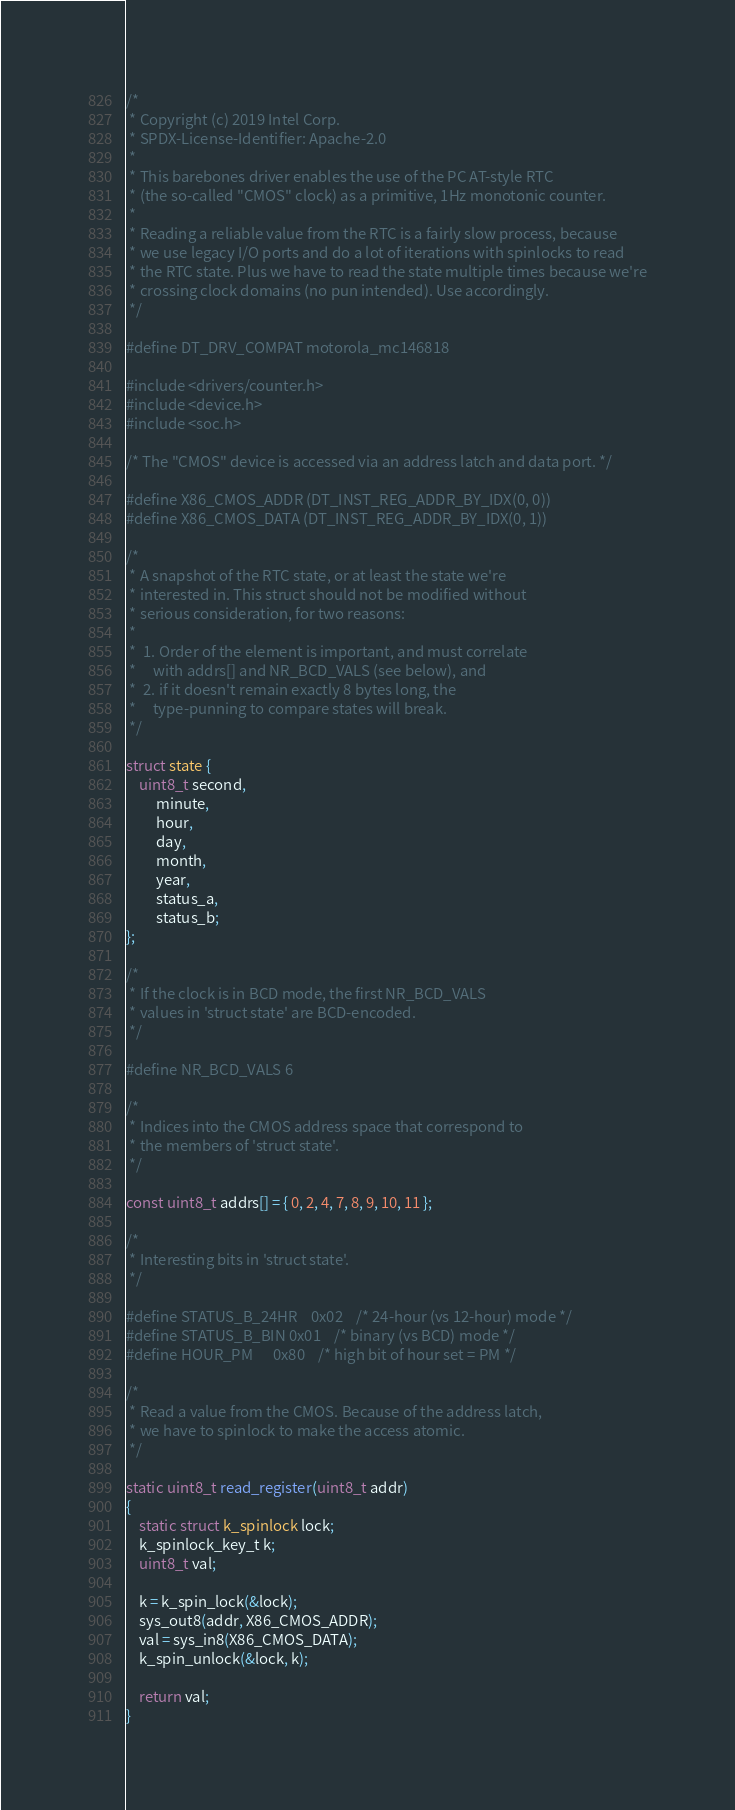<code> <loc_0><loc_0><loc_500><loc_500><_C_>/*
 * Copyright (c) 2019 Intel Corp.
 * SPDX-License-Identifier: Apache-2.0
 *
 * This barebones driver enables the use of the PC AT-style RTC
 * (the so-called "CMOS" clock) as a primitive, 1Hz monotonic counter.
 *
 * Reading a reliable value from the RTC is a fairly slow process, because
 * we use legacy I/O ports and do a lot of iterations with spinlocks to read
 * the RTC state. Plus we have to read the state multiple times because we're
 * crossing clock domains (no pun intended). Use accordingly.
 */

#define DT_DRV_COMPAT motorola_mc146818

#include <drivers/counter.h>
#include <device.h>
#include <soc.h>

/* The "CMOS" device is accessed via an address latch and data port. */

#define X86_CMOS_ADDR (DT_INST_REG_ADDR_BY_IDX(0, 0))
#define X86_CMOS_DATA (DT_INST_REG_ADDR_BY_IDX(0, 1))

/*
 * A snapshot of the RTC state, or at least the state we're
 * interested in. This struct should not be modified without
 * serious consideration, for two reasons:
 *
 *	1. Order of the element is important, and must correlate
 *	   with addrs[] and NR_BCD_VALS (see below), and
 *	2. if it doesn't remain exactly 8 bytes long, the
 *	   type-punning to compare states will break.
 */

struct state {
	uint8_t second,
	     minute,
	     hour,
	     day,
	     month,
	     year,
	     status_a,
	     status_b;
};

/*
 * If the clock is in BCD mode, the first NR_BCD_VALS
 * values in 'struct state' are BCD-encoded.
 */

#define NR_BCD_VALS 6

/*
 * Indices into the CMOS address space that correspond to
 * the members of 'struct state'.
 */

const uint8_t addrs[] = { 0, 2, 4, 7, 8, 9, 10, 11 };

/*
 * Interesting bits in 'struct state'.
 */

#define STATUS_B_24HR	0x02	/* 24-hour (vs 12-hour) mode */
#define STATUS_B_BIN	0x01	/* binary (vs BCD) mode */
#define HOUR_PM		0x80	/* high bit of hour set = PM */

/*
 * Read a value from the CMOS. Because of the address latch,
 * we have to spinlock to make the access atomic.
 */

static uint8_t read_register(uint8_t addr)
{
	static struct k_spinlock lock;
	k_spinlock_key_t k;
	uint8_t val;

	k = k_spin_lock(&lock);
	sys_out8(addr, X86_CMOS_ADDR);
	val = sys_in8(X86_CMOS_DATA);
	k_spin_unlock(&lock, k);

	return val;
}
</code> 